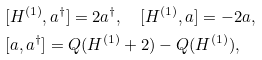<formula> <loc_0><loc_0><loc_500><loc_500>& [ H ^ { ( 1 ) } , a ^ { \dagger } ] = 2 a ^ { \dagger } , \quad [ H ^ { ( 1 ) } , a ] = - 2 a , \\ & [ a , a ^ { \dagger } ] = Q ( H ^ { ( 1 ) } + 2 ) - Q ( H ^ { ( 1 ) } ) ,</formula> 